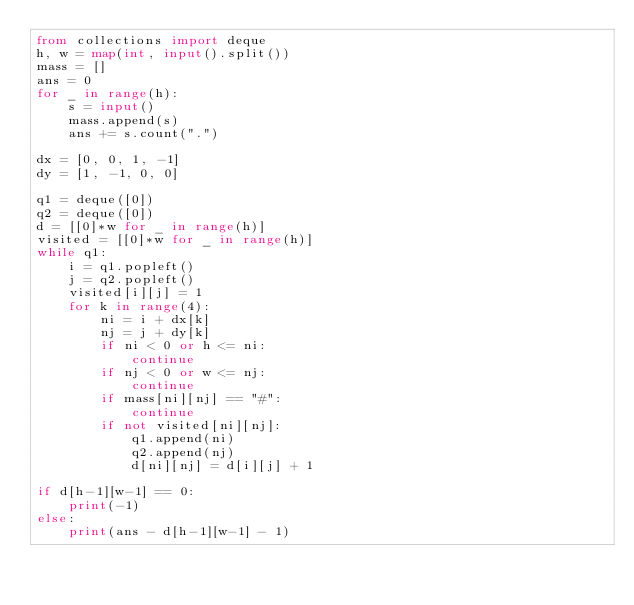<code> <loc_0><loc_0><loc_500><loc_500><_Python_>from collections import deque
h, w = map(int, input().split())
mass = []
ans = 0
for _ in range(h):
    s = input()
    mass.append(s)
    ans += s.count(".")

dx = [0, 0, 1, -1]
dy = [1, -1, 0, 0]

q1 = deque([0])
q2 = deque([0])
d = [[0]*w for _ in range(h)]
visited = [[0]*w for _ in range(h)]
while q1:
    i = q1.popleft()
    j = q2.popleft()
    visited[i][j] = 1
    for k in range(4):
        ni = i + dx[k]
        nj = j + dy[k]
        if ni < 0 or h <= ni:
            continue
        if nj < 0 or w <= nj:
            continue
        if mass[ni][nj] == "#":
            continue
        if not visited[ni][nj]:
            q1.append(ni)
            q2.append(nj)
            d[ni][nj] = d[i][j] + 1

if d[h-1][w-1] == 0:
    print(-1)
else:
    print(ans - d[h-1][w-1] - 1)

</code> 